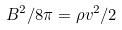<formula> <loc_0><loc_0><loc_500><loc_500>B ^ { 2 } / 8 \pi = \rho v ^ { 2 } / 2</formula> 